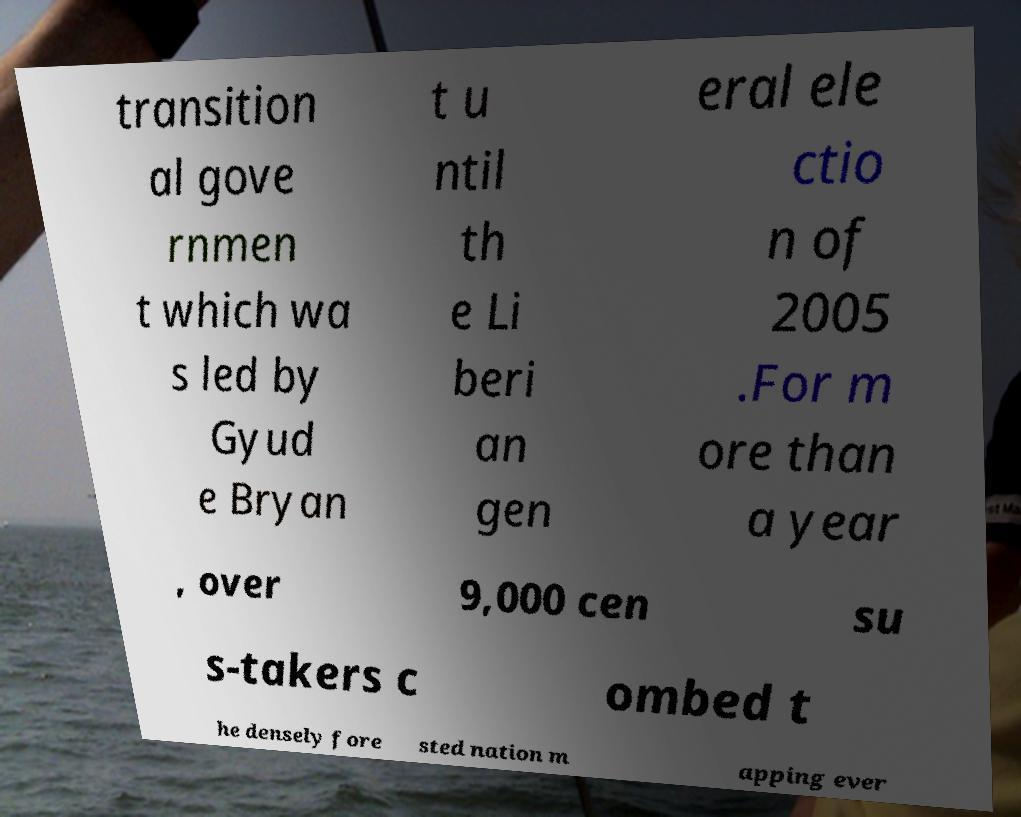Please identify and transcribe the text found in this image. transition al gove rnmen t which wa s led by Gyud e Bryan t u ntil th e Li beri an gen eral ele ctio n of 2005 .For m ore than a year , over 9,000 cen su s-takers c ombed t he densely fore sted nation m apping ever 